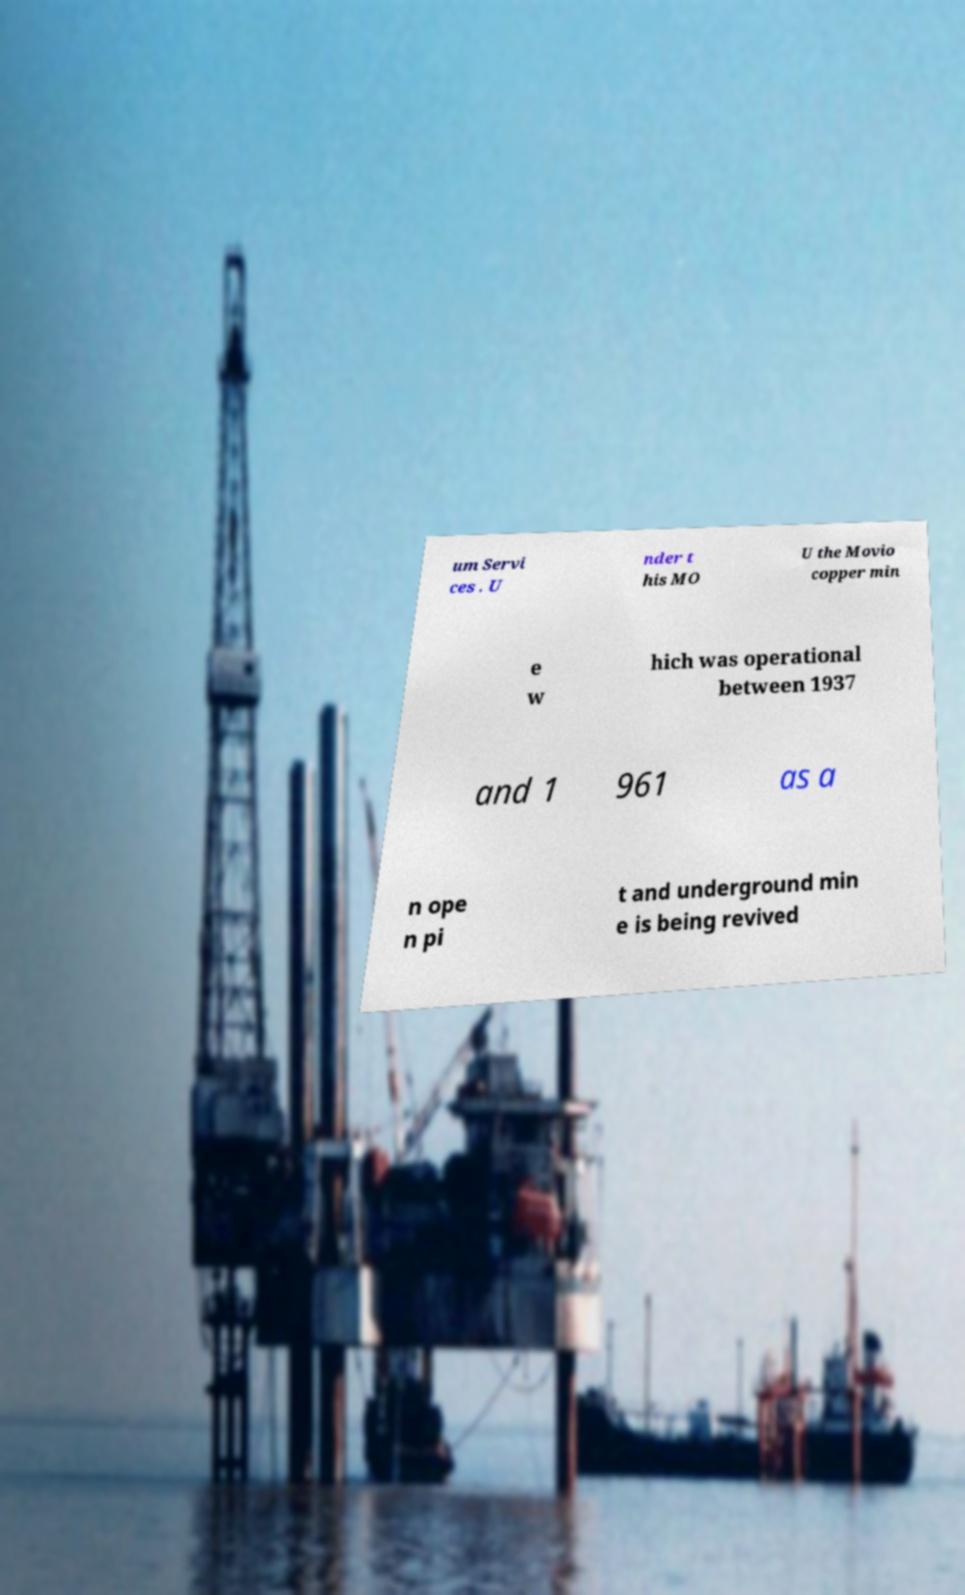Please read and relay the text visible in this image. What does it say? um Servi ces . U nder t his MO U the Movio copper min e w hich was operational between 1937 and 1 961 as a n ope n pi t and underground min e is being revived 